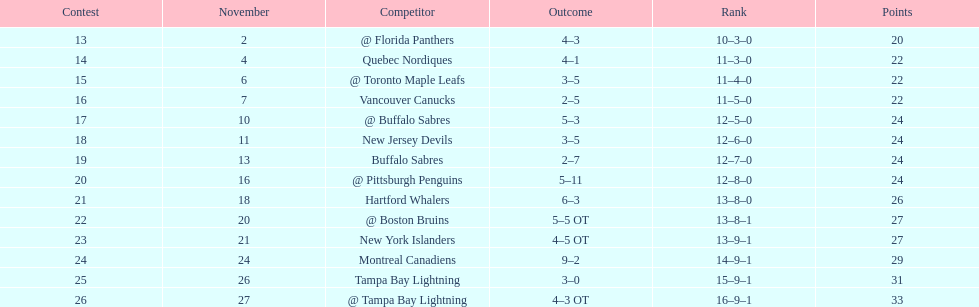What was the total penalty minutes that dave brown had on the 1993-1994 flyers? 137. 